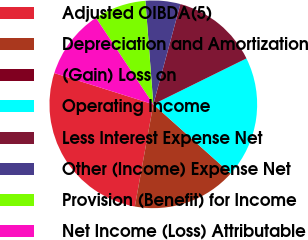Convert chart to OTSL. <chart><loc_0><loc_0><loc_500><loc_500><pie_chart><fcel>Adjusted OIBDA(5)<fcel>Depreciation and Amortization<fcel>(Gain) Loss on<fcel>Operating Income<fcel>Less Interest Expense Net<fcel>Other (Income) Expense Net<fcel>Provision (Benefit) for Income<fcel>Net Income (Loss) Attributable<nl><fcel>27.01%<fcel>16.21%<fcel>0.01%<fcel>18.91%<fcel>13.51%<fcel>5.41%<fcel>8.11%<fcel>10.81%<nl></chart> 